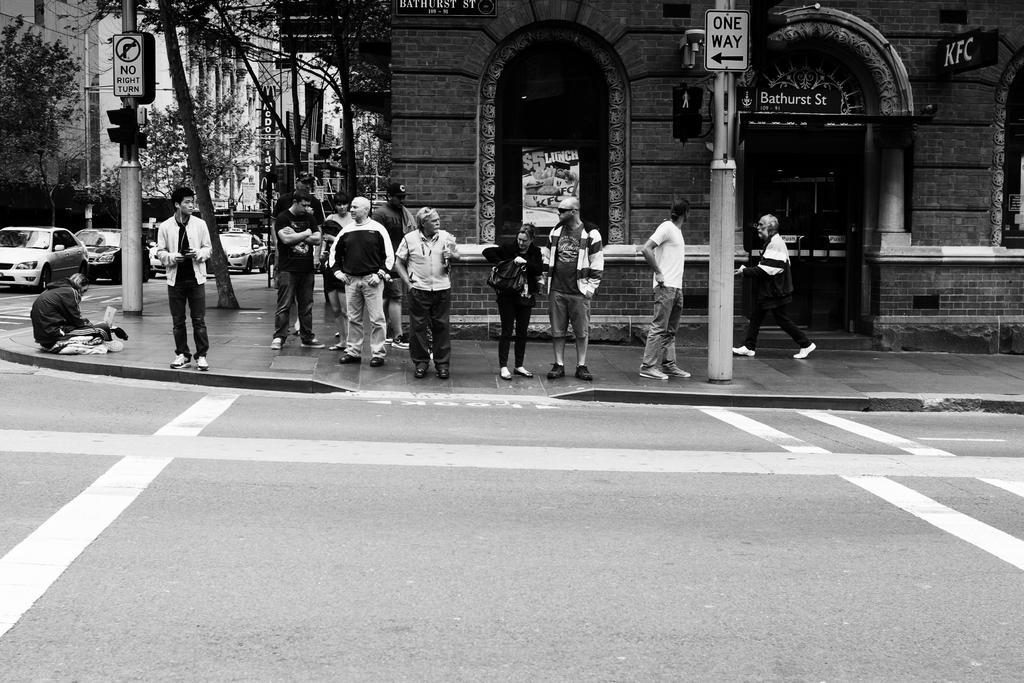Could you give a brief overview of what you see in this image? In this picture I can see the road in front and in the middle of this picture I can see the footpath on which there are number of people, 2 poles on which there are boards and I see something is written and on the left side of this picture I can see number of trees, cars and I can see number of buildings. On the top of this picture I can see 3 boards on which there are words written. 